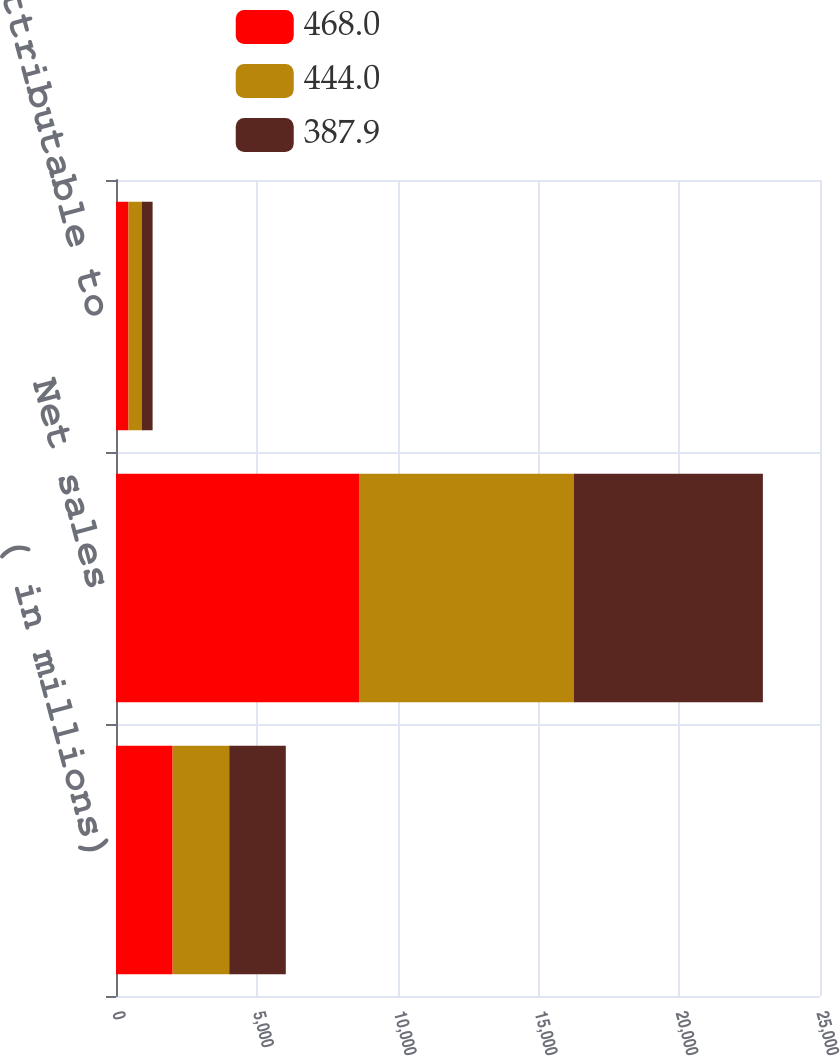Convert chart. <chart><loc_0><loc_0><loc_500><loc_500><stacked_bar_chart><ecel><fcel>( in millions)<fcel>Net sales<fcel>Net earnings attributable to<nl><fcel>468<fcel>2011<fcel>8630.9<fcel>444<nl><fcel>444<fcel>2010<fcel>7630<fcel>468<nl><fcel>387.9<fcel>2009<fcel>6710.4<fcel>387.9<nl></chart> 